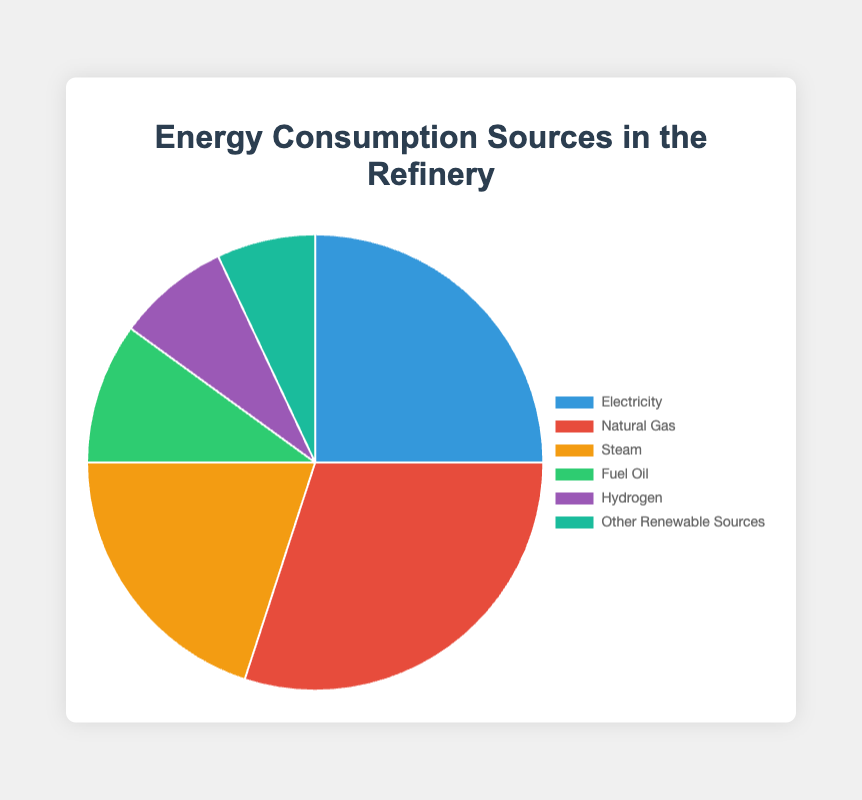What's the most used energy source in the refinery? The chart shows different energy sources and their usage percentages. Natural Gas has the highest percentage at 30%
Answer: Natural Gas Which two energy sources have the closest usage percentages? By comparing the usage percentages, Steam at 20% and Fuel Oil at 10% are the closest before considering Hydrogen and Other Renewable Sources close as well at 8% and 7%
Answer: Hydrogen and Other Renewable Sources What's the total percentage of energy consumption from non-renewable sources? Non-renewable sources include Electricity, Natural Gas, Steam, Fuel Oil, and Hydrogen. Summing these: 25% + 30% + 20% + 10% + 8% = 93%
Answer: 93% How much more is the energy consumption of Natural Gas than Hydrogen? The chart shows Natural Gas at 30% and Hydrogen at 8%. The difference is 30% - 8% = 22%
Answer: 22% Which energy source contributes the least to the total energy consumption? By looking at the percentages, Other Renewable Sources contribute the least at 7%
Answer: Other Renewable Sources What is the combined usage percentage of Fuel Oil and Hydrogen? Fuel Oil is at 10% and Hydrogen is at 8%. Adding them gives 10% + 8% = 18%
Answer: 18% How does the usage of Steam compare to the combined usage of Fuel Oil and Other Renewable Sources? Steam is at 20%, while Fuel Oil and Other Renewable Sources together are 10% + 7% = 17%. Comparing 20% and 17%, Steam has a higher usage
Answer: Steam has a higher usage What is the average usage percentage of all the energy sources? The total percentage is 100%, and there are 6 energy sources. The average is 100% / 6 ≈ 16.67%
Answer: 16.67% Between Electricity and Steam, which has a higher usage percentage, and by how much? Electricity is at 25% and Steam is at 20%. The difference is 25% - 20% = 5%
Answer: Electricity by 5% 